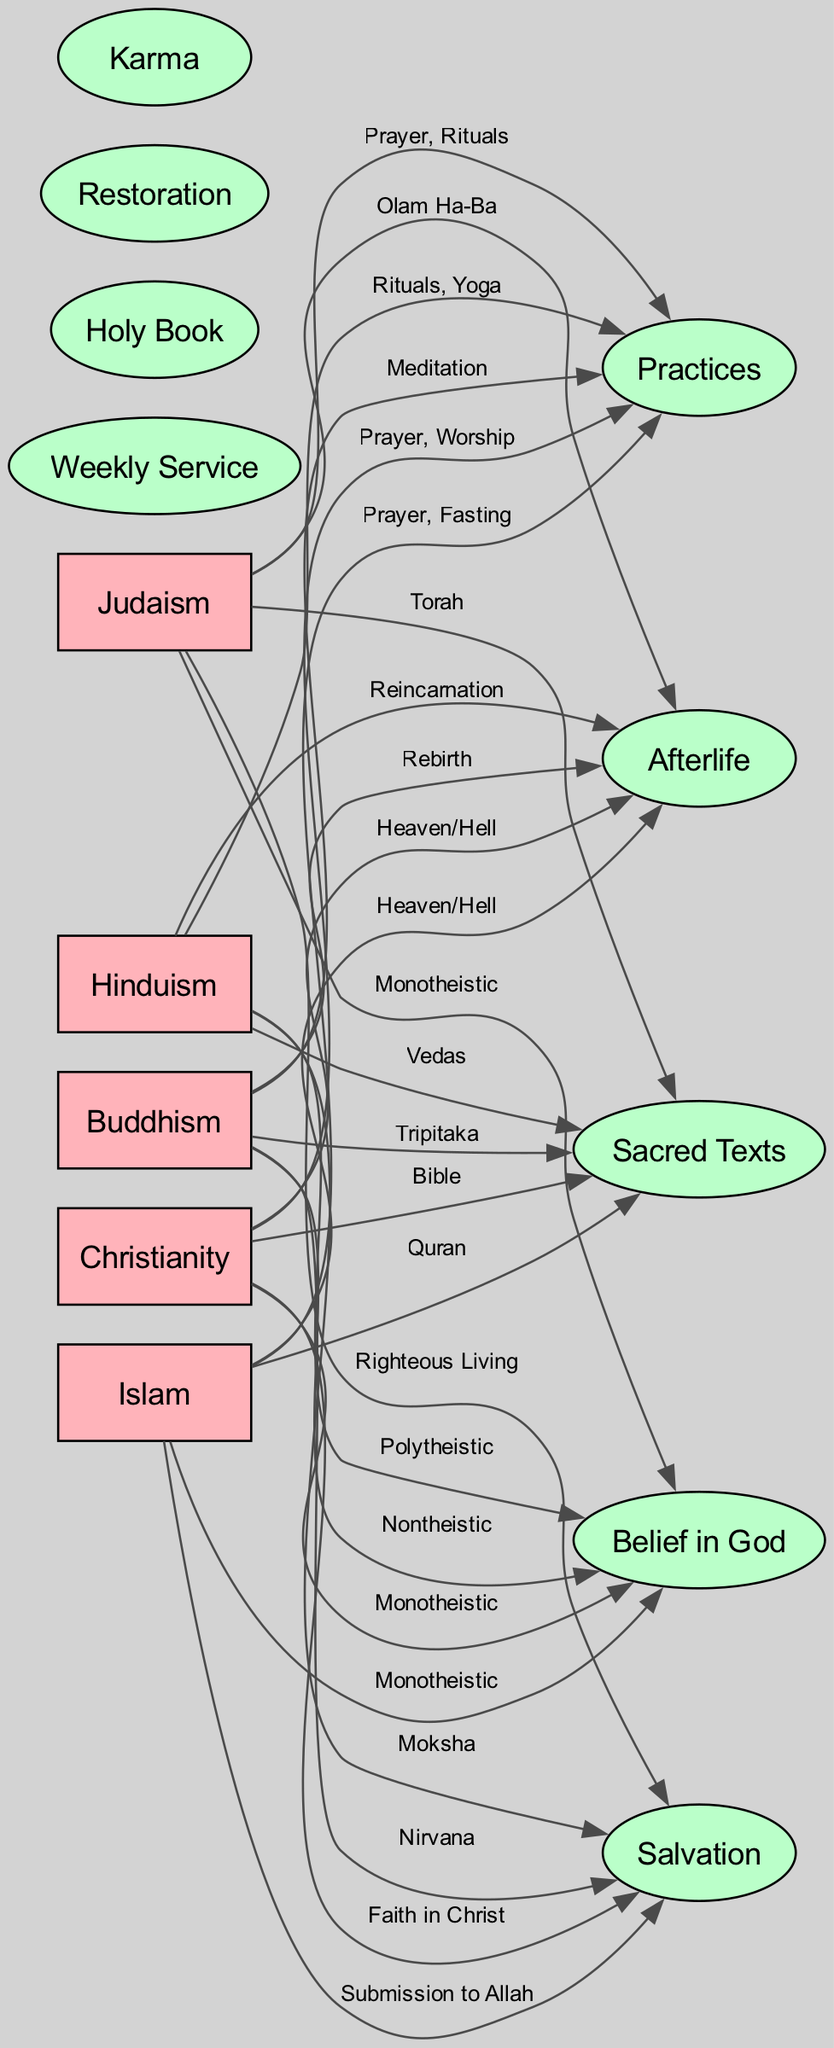What is the sacred text of Islam? In the diagram, Islam is connected to the node labeled "Sacred Texts" with the edge labeled "Quran." This indicates that the Quran is the sacred text associated with Islam.
Answer: Quran Which religion believes in Karma? The edge from Hinduism to the "Karma" concept indicates that Hinduism is the religion associated with the belief in Karma. Hence, by looking at the diagram, we can determine that Hinduism believes in Karma.
Answer: Hinduism How many religions are depicted in the diagram? By counting the nodes labeled with the names of the religions (Christianity, Islam, Hinduism, Buddhism, Judaism), we find a total of five religions represented in the diagram.
Answer: 5 What is the salvation belief of Buddhism? In the diagram, Buddhism connects to the node labeled "Salvation" with the edge labeled "Nirvana." This indicates that the belief in salvation for Buddhism is Nirvana.
Answer: Nirvana How are Christianity and Islam related in terms of belief in God? Both Christianity and Islam connect to the node labeled "Belief in God" with edges labeled "Monotheistic." This relationship shows that both religions share the belief that there is one God.
Answer: Monotheistic What are the weekly service practices of Christianity? The diagram shows the edge connecting Christianity to the "Practices" node labeled "Prayer, Worship." This indicates that Christianity includes prayer and worship as part of its weekly services.
Answer: Prayer, Worship Which religion has "Heaven/Hell" as its belief regarding the afterlife? Both Christianity and Islam connect to the node labeled "Afterlife" with edges labeled "Heaven/Hell." So both of these religions share this belief about the afterlife.
Answer: Christianity, Islam What type of practices are included in Hinduism? The diagram shows the edge from Hinduism to the "Practices" node labeled "Rituals, Yoga." This reveals that rituals and yoga are the practices associated with Hinduism.
Answer: Rituals, Yoga What is the afterlife belief in Judaism? In the diagram, the edge from Judaism to the "Afterlife" node is labeled "Olam Ha-Ba," indicating that Judaism believes in the afterlife concept of Olam Ha-Ba.
Answer: Olam Ha-Ba 